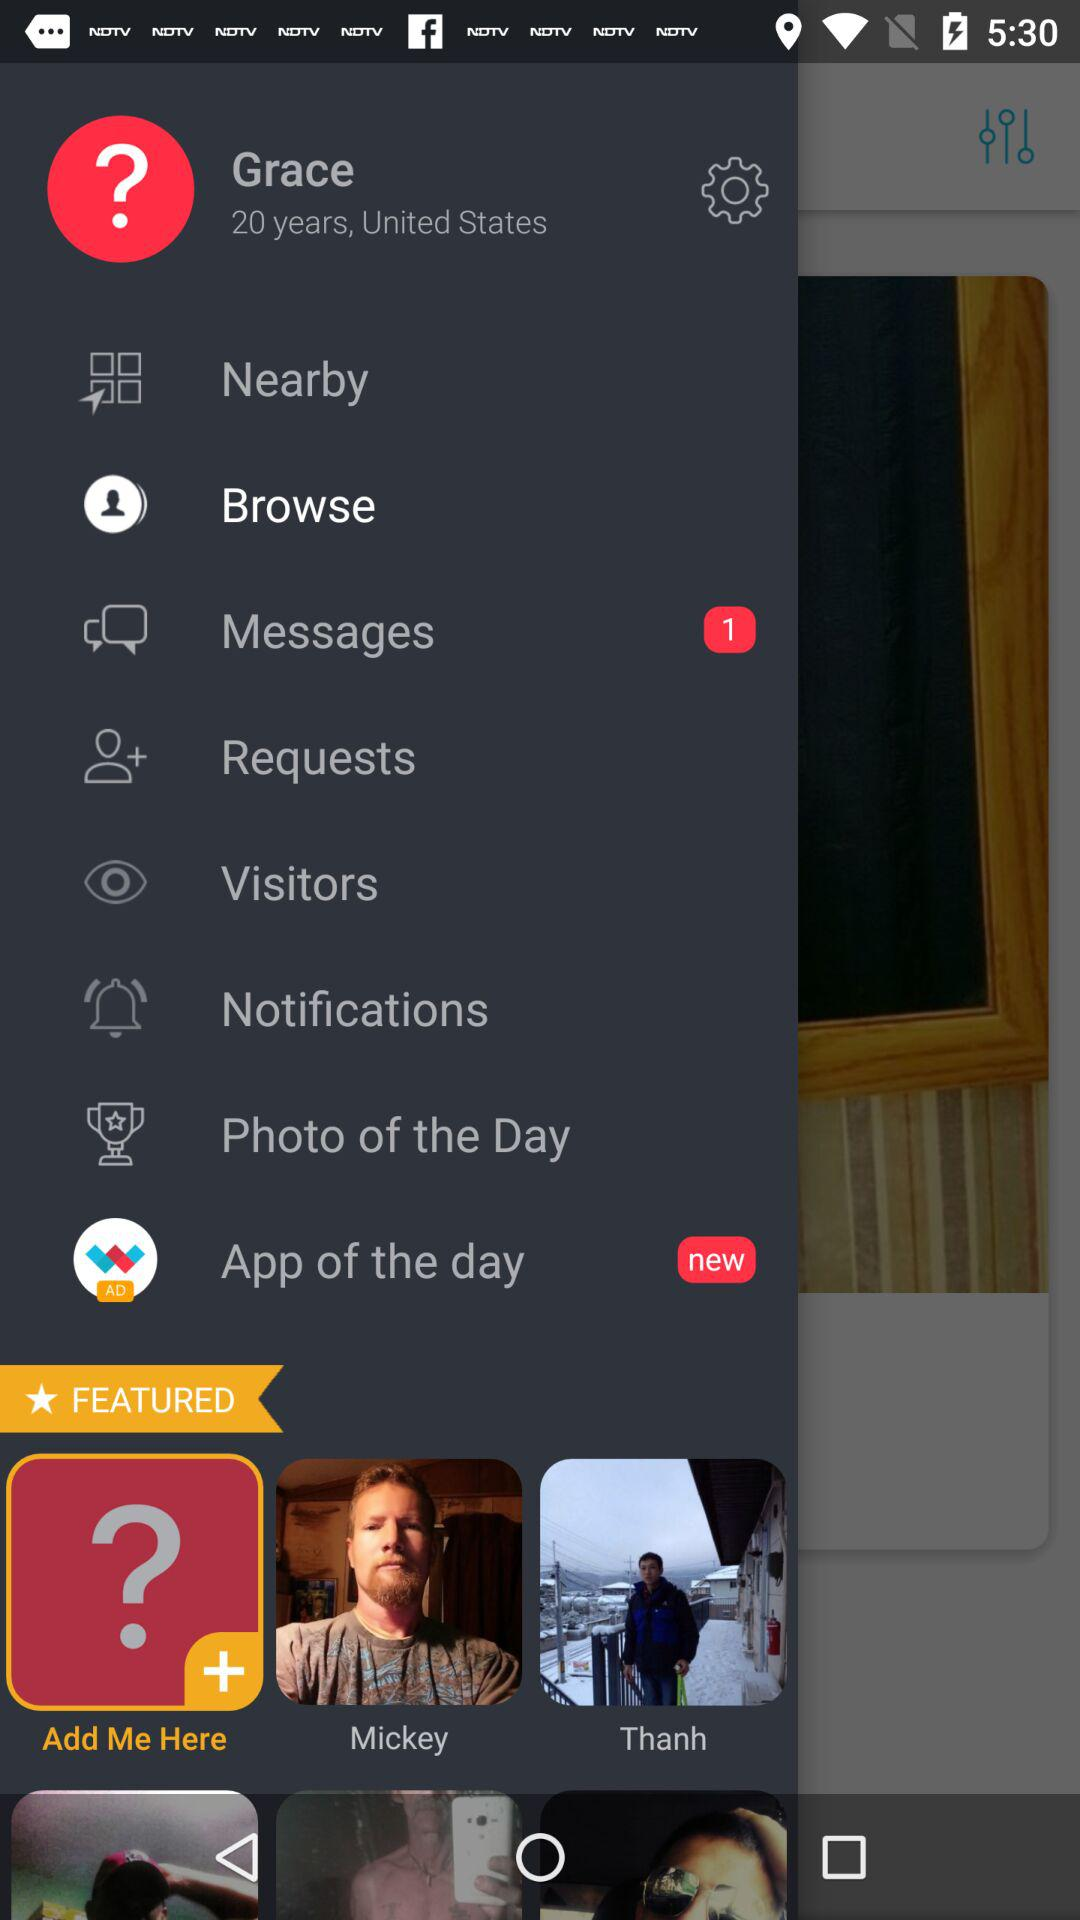What is the name of the user? The name of the user is Grace. 